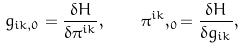Convert formula to latex. <formula><loc_0><loc_0><loc_500><loc_500>g _ { i k , 0 } = \frac { \delta H } { \delta \pi ^ { i k } } , \quad \pi ^ { i k } , _ { 0 } = \frac { \delta H } { \delta g _ { i k } } ,</formula> 